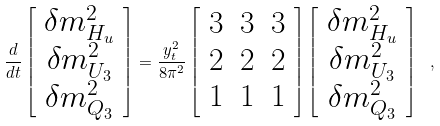Convert formula to latex. <formula><loc_0><loc_0><loc_500><loc_500>\frac { d } { d t } \left [ \begin{array} { c } \delta m _ { H _ { u } } ^ { 2 } \\ \delta m _ { U _ { 3 } } ^ { 2 } \\ \delta m _ { Q _ { 3 } } ^ { 2 } \end{array} \right ] = \frac { y _ { t } ^ { 2 } } { 8 \pi ^ { 2 } } \left [ \begin{array} { c c c } 3 & 3 & 3 \\ 2 & 2 & 2 \\ 1 & 1 & 1 \end{array} \right ] \left [ \begin{array} { c } \delta m _ { H _ { u } } ^ { 2 } \\ \delta m _ { U _ { 3 } } ^ { 2 } \\ \delta m _ { Q _ { 3 } } ^ { 2 } \end{array} \right ] \ ,</formula> 